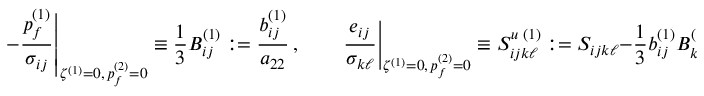Convert formula to latex. <formula><loc_0><loc_0><loc_500><loc_500>- \frac { p _ { f } ^ { ( 1 ) } } { \sigma _ { i j } } \right | _ { \zeta ^ { ( 1 ) } = 0 , \, p _ { f } ^ { ( 2 ) } = 0 } \equiv \frac { 1 } { 3 } B _ { i j } ^ { ( 1 ) } \colon = \frac { b _ { i j } ^ { ( 1 ) } } { a _ { 2 2 } } \, , \quad \frac { e _ { i j } } { \sigma _ { k \ell } } \right | _ { \zeta ^ { ( 1 ) } = 0 , \, p _ { f } ^ { ( 2 ) } = 0 } \equiv S _ { i j k \ell } ^ { u \, ( 1 ) } \colon = S _ { i j k \ell } - \frac { 1 } { 3 } b _ { i j } ^ { ( 1 ) } B _ { k \ell } ^ { ( 1 ) } \, ,</formula> 